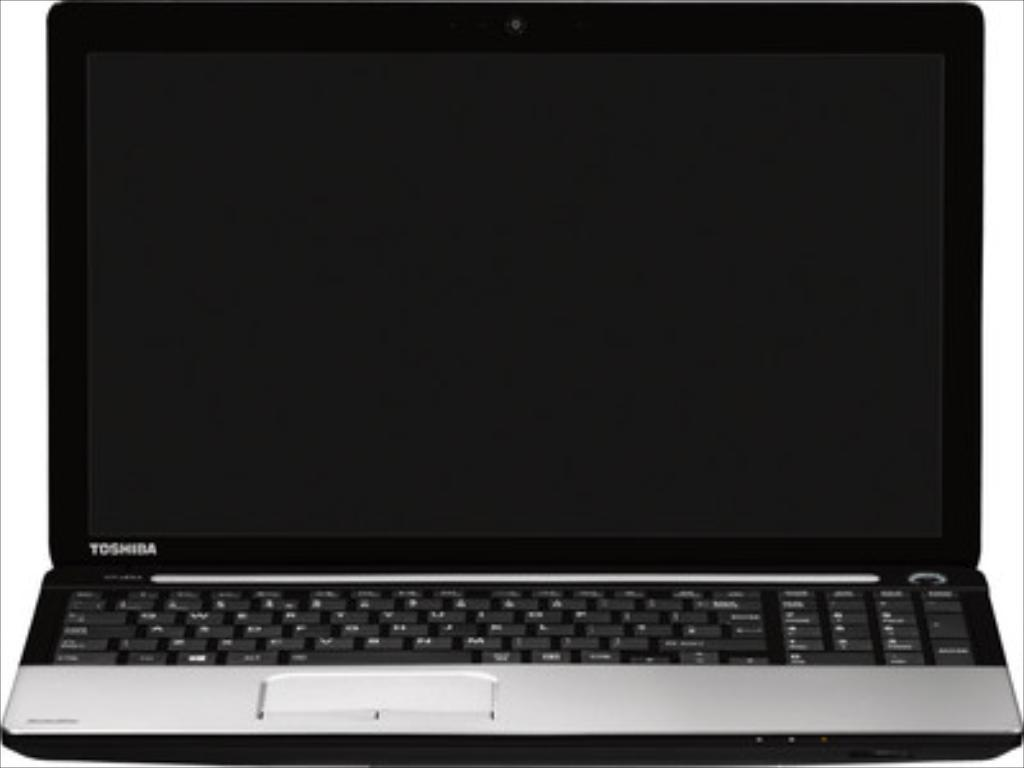<image>
Render a clear and concise summary of the photo. A laptop with black keys that is the toshiba brand. 